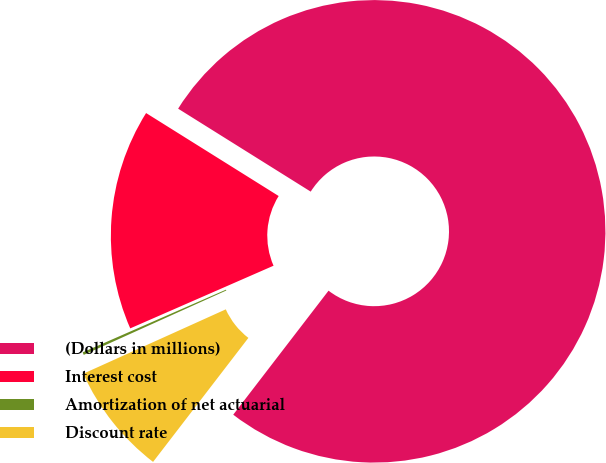<chart> <loc_0><loc_0><loc_500><loc_500><pie_chart><fcel>(Dollars in millions)<fcel>Interest cost<fcel>Amortization of net actuarial<fcel>Discount rate<nl><fcel>76.53%<fcel>15.46%<fcel>0.19%<fcel>7.82%<nl></chart> 